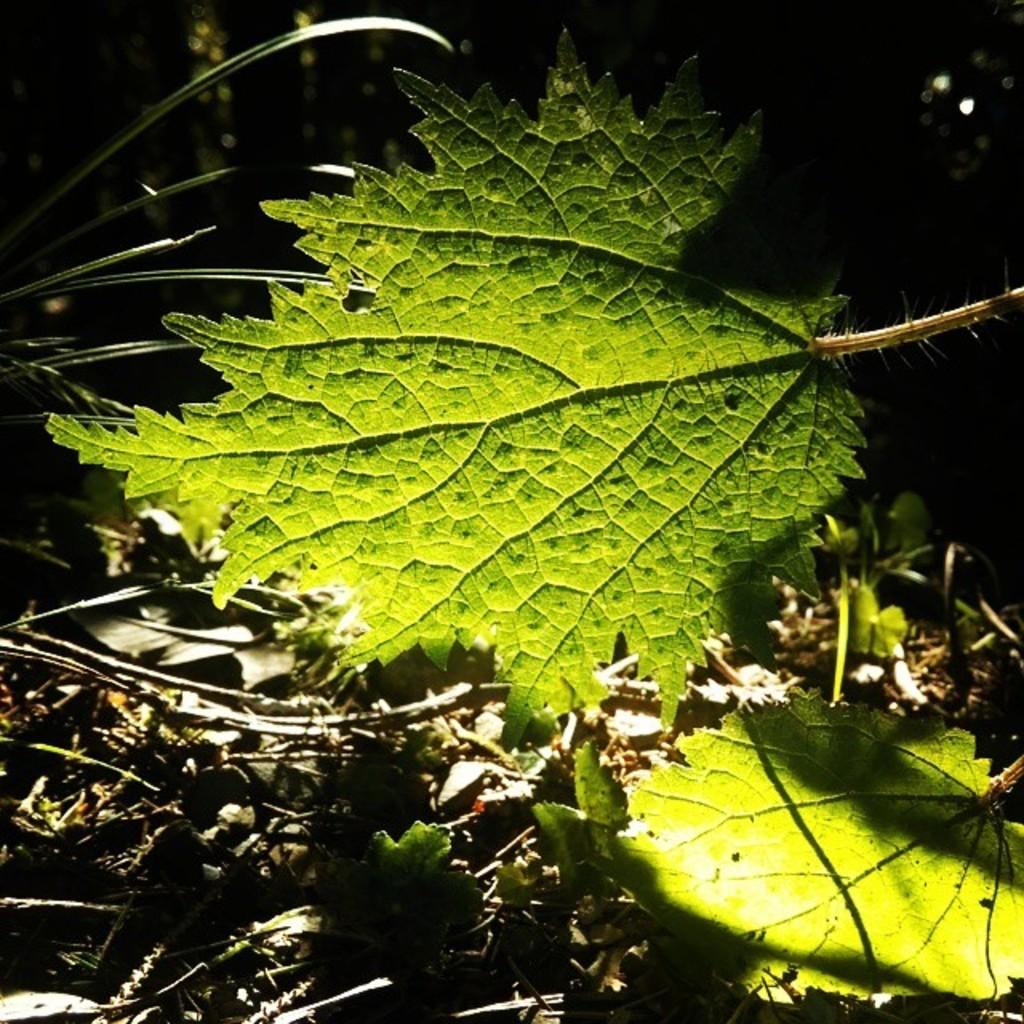Please provide a concise description of this image. In front of the image there are leaves. At the bottom of the image there are dried leaves and branches on the surface. 